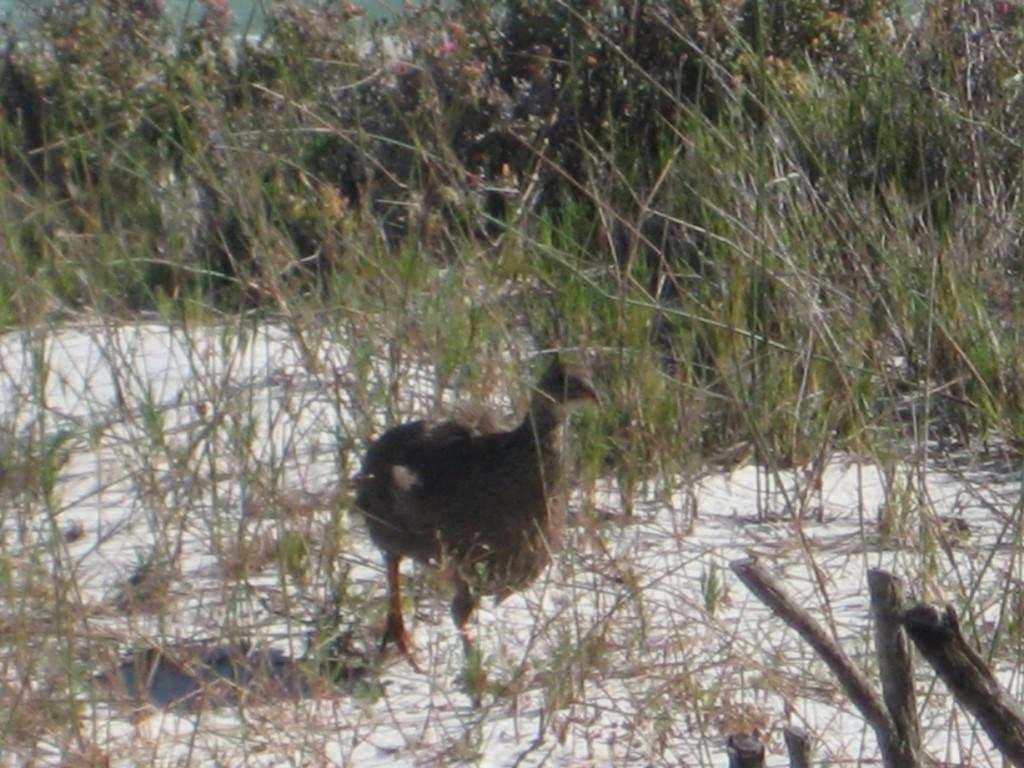What type of animal can be seen in the image? There is a bird in the image. What type of terrain is visible in the image? There is grass in the image. What material is used for the objects in the image? There are wooden objects in the image. What other living organisms are present in the image? There are plants in the image. What weather condition is depicted in the image? There is snow in the image. What type of fuel is being used by the volcano in the image? There is no volcano present in the image, so the question about fuel is not applicable. 